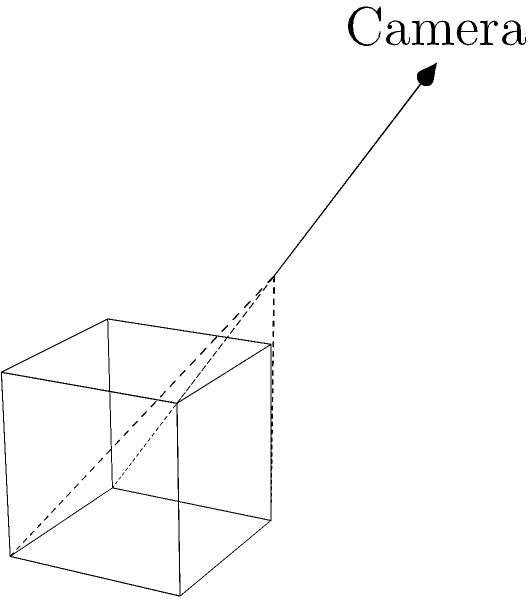In computer vision, estimating the volume of 3D objects from 2D camera perspectives is a challenging task. Consider a cube with unit length sides captured by a single camera, as shown in the diagram. What are the key challenges in accurately estimating the cube's volume from this single perspective, and how might multiple views or additional information improve the estimation? To estimate the volume of a 3D object from 2D camera perspectives, we need to consider several factors:

1. Perspective distortion: Objects further from the camera appear smaller, making it difficult to accurately determine true dimensions.

2. Occlusion: Parts of the object may be hidden from view, leading to incomplete information about its shape and size.

3. Lack of depth information: A single 2D image doesn't provide direct depth measurements, which are crucial for volume estimation.

4. Scale ambiguity: Without a known reference size in the image, it's impossible to determine the absolute scale of the object.

To improve the estimation:

1. Multiple views: Capturing images from different angles can provide more complete information about the object's shape and dimensions.

2. Stereo vision: Using two cameras can help recover depth information through triangulation.

3. Structured light: Projecting known patterns onto the object can help recover its 3D structure.

4. Reference objects: Including objects of known size in the scene can provide scale information.

5. Depth sensors: Using technologies like LiDAR or time-of-flight cameras can directly capture depth information.

6. Machine learning: Training models on large datasets of 3D objects and their 2D projections can help in estimating volumes from limited information.

The volume of a cube is given by $V = s^3$, where $s$ is the length of a side. However, accurately determining $s$ from a single 2D perspective is challenging due to the factors mentioned above.
Answer: Multiple views, depth information, and reference objects are crucial for accurate volume estimation from 2D images. 